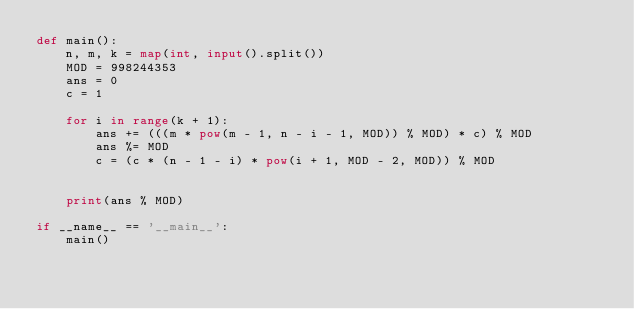<code> <loc_0><loc_0><loc_500><loc_500><_Python_>def main():
    n, m, k = map(int, input().split())
    MOD = 998244353
    ans = 0
    c = 1

    for i in range(k + 1):
        ans += (((m * pow(m - 1, n - i - 1, MOD)) % MOD) * c) % MOD
        ans %= MOD
        c = (c * (n - 1 - i) * pow(i + 1, MOD - 2, MOD)) % MOD
        
        
    print(ans % MOD)
    
if __name__ == '__main__':
    main()</code> 